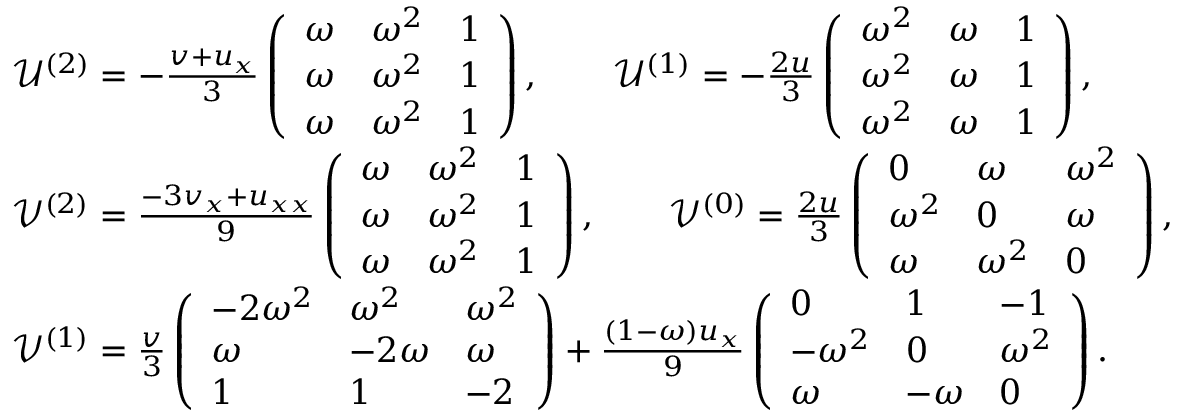Convert formula to latex. <formula><loc_0><loc_0><loc_500><loc_500>\begin{array} { r l } & { \mathcal { U } ^ { ( 2 ) } = - \frac { v + u _ { x } } { 3 } \left ( \begin{array} { l l l } { \omega } & { \omega ^ { 2 } } & { 1 } \\ { \omega } & { \omega ^ { 2 } } & { 1 } \\ { \omega } & { \omega ^ { 2 } } & { 1 } \end{array} \right ) , \quad \mathcal { U } ^ { ( 1 ) } = - \frac { 2 u } { 3 } \left ( \begin{array} { l l l } { \omega ^ { 2 } } & { \omega } & { 1 } \\ { \omega ^ { 2 } } & { \omega } & { 1 } \\ { \omega ^ { 2 } } & { \omega } & { 1 } \end{array} \right ) , } \\ & { \mathcal { V } ^ { ( 2 ) } = \frac { - 3 v _ { x } + u _ { x x } } { 9 } \left ( \begin{array} { l l l } { \omega } & { \omega ^ { 2 } } & { 1 } \\ { \omega } & { \omega ^ { 2 } } & { 1 } \\ { \omega } & { \omega ^ { 2 } } & { 1 } \end{array} \right ) , \quad \mathcal { V } ^ { ( 0 ) } = \frac { 2 u } { 3 } \left ( \begin{array} { l l l } { 0 } & { \omega } & { \omega ^ { 2 } } \\ { \omega ^ { 2 } } & { 0 } & { \omega } \\ { \omega } & { \omega ^ { 2 } } & { 0 } \end{array} \right ) , } \\ & { \mathcal { V } ^ { ( 1 ) } = \frac { v } { 3 } \left ( \begin{array} { l l l } { - 2 \omega ^ { 2 } } & { \omega ^ { 2 } } & { \omega ^ { 2 } } \\ { \omega } & { - 2 \omega } & { \omega } \\ { 1 } & { 1 } & { - 2 } \end{array} \right ) + \frac { ( 1 - \omega ) u _ { x } } { 9 } \left ( \begin{array} { l l l } { 0 } & { 1 } & { - 1 } \\ { - \omega ^ { 2 } } & { 0 } & { \omega ^ { 2 } } \\ { \omega } & { - \omega } & { 0 } \end{array} \right ) . } \end{array}</formula> 